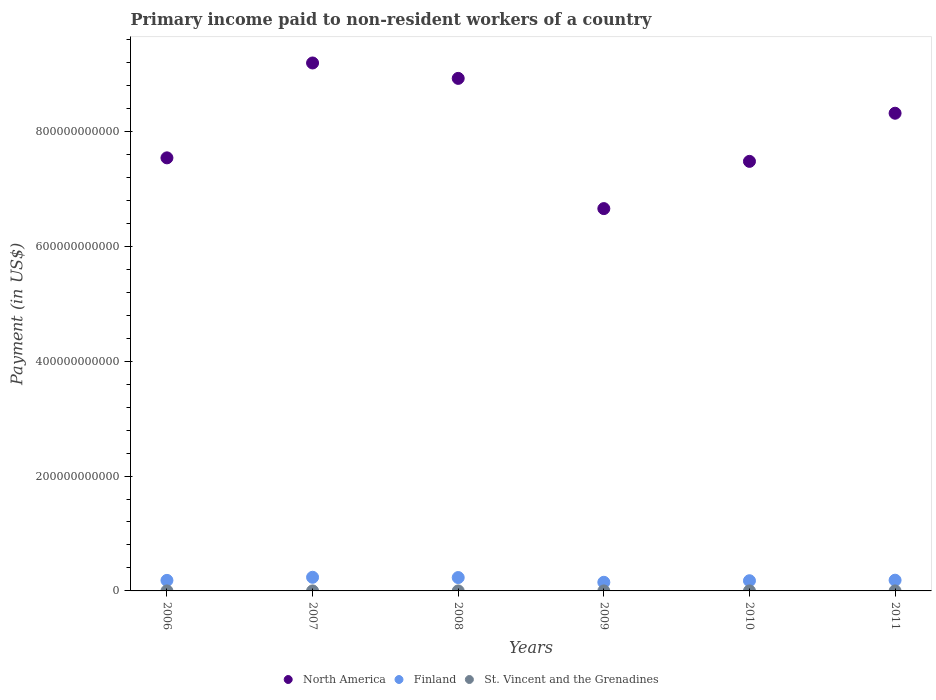How many different coloured dotlines are there?
Provide a succinct answer. 3. Is the number of dotlines equal to the number of legend labels?
Your answer should be compact. Yes. What is the amount paid to workers in Finland in 2009?
Provide a short and direct response. 1.50e+1. Across all years, what is the maximum amount paid to workers in North America?
Offer a terse response. 9.19e+11. Across all years, what is the minimum amount paid to workers in St. Vincent and the Grenadines?
Give a very brief answer. 9.53e+06. In which year was the amount paid to workers in North America maximum?
Keep it short and to the point. 2007. What is the total amount paid to workers in St. Vincent and the Grenadines in the graph?
Offer a very short reply. 7.30e+07. What is the difference between the amount paid to workers in North America in 2009 and that in 2010?
Ensure brevity in your answer.  -8.22e+1. What is the difference between the amount paid to workers in North America in 2006 and the amount paid to workers in Finland in 2010?
Keep it short and to the point. 7.36e+11. What is the average amount paid to workers in St. Vincent and the Grenadines per year?
Give a very brief answer. 1.22e+07. In the year 2006, what is the difference between the amount paid to workers in Finland and amount paid to workers in North America?
Provide a succinct answer. -7.36e+11. In how many years, is the amount paid to workers in St. Vincent and the Grenadines greater than 800000000000 US$?
Your response must be concise. 0. What is the ratio of the amount paid to workers in St. Vincent and the Grenadines in 2006 to that in 2010?
Provide a succinct answer. 1.07. Is the amount paid to workers in North America in 2006 less than that in 2010?
Provide a short and direct response. No. Is the difference between the amount paid to workers in Finland in 2007 and 2011 greater than the difference between the amount paid to workers in North America in 2007 and 2011?
Ensure brevity in your answer.  No. What is the difference between the highest and the second highest amount paid to workers in St. Vincent and the Grenadines?
Provide a short and direct response. 8.47e+04. What is the difference between the highest and the lowest amount paid to workers in Finland?
Provide a short and direct response. 8.73e+09. In how many years, is the amount paid to workers in North America greater than the average amount paid to workers in North America taken over all years?
Make the answer very short. 3. Is the sum of the amount paid to workers in Finland in 2006 and 2007 greater than the maximum amount paid to workers in St. Vincent and the Grenadines across all years?
Your answer should be compact. Yes. Does the amount paid to workers in St. Vincent and the Grenadines monotonically increase over the years?
Your answer should be compact. No. Is the amount paid to workers in St. Vincent and the Grenadines strictly greater than the amount paid to workers in Finland over the years?
Your response must be concise. No. How many dotlines are there?
Give a very brief answer. 3. How many years are there in the graph?
Offer a terse response. 6. What is the difference between two consecutive major ticks on the Y-axis?
Make the answer very short. 2.00e+11. Where does the legend appear in the graph?
Make the answer very short. Bottom center. How are the legend labels stacked?
Keep it short and to the point. Horizontal. What is the title of the graph?
Provide a short and direct response. Primary income paid to non-resident workers of a country. What is the label or title of the Y-axis?
Offer a terse response. Payment (in US$). What is the Payment (in US$) of North America in 2006?
Your response must be concise. 7.54e+11. What is the Payment (in US$) of Finland in 2006?
Your answer should be compact. 1.83e+1. What is the Payment (in US$) in St. Vincent and the Grenadines in 2006?
Your answer should be very brief. 1.36e+07. What is the Payment (in US$) of North America in 2007?
Your answer should be very brief. 9.19e+11. What is the Payment (in US$) of Finland in 2007?
Provide a short and direct response. 2.38e+1. What is the Payment (in US$) of St. Vincent and the Grenadines in 2007?
Your answer should be very brief. 1.34e+07. What is the Payment (in US$) of North America in 2008?
Provide a succinct answer. 8.92e+11. What is the Payment (in US$) in Finland in 2008?
Offer a terse response. 2.33e+1. What is the Payment (in US$) in St. Vincent and the Grenadines in 2008?
Keep it short and to the point. 1.01e+07. What is the Payment (in US$) of North America in 2009?
Your answer should be compact. 6.66e+11. What is the Payment (in US$) in Finland in 2009?
Your answer should be compact. 1.50e+1. What is the Payment (in US$) in St. Vincent and the Grenadines in 2009?
Offer a very short reply. 1.37e+07. What is the Payment (in US$) of North America in 2010?
Ensure brevity in your answer.  7.48e+11. What is the Payment (in US$) of Finland in 2010?
Make the answer very short. 1.77e+1. What is the Payment (in US$) of St. Vincent and the Grenadines in 2010?
Your answer should be compact. 1.27e+07. What is the Payment (in US$) in North America in 2011?
Give a very brief answer. 8.32e+11. What is the Payment (in US$) of Finland in 2011?
Ensure brevity in your answer.  1.87e+1. What is the Payment (in US$) in St. Vincent and the Grenadines in 2011?
Keep it short and to the point. 9.53e+06. Across all years, what is the maximum Payment (in US$) of North America?
Give a very brief answer. 9.19e+11. Across all years, what is the maximum Payment (in US$) in Finland?
Offer a very short reply. 2.38e+1. Across all years, what is the maximum Payment (in US$) in St. Vincent and the Grenadines?
Your answer should be compact. 1.37e+07. Across all years, what is the minimum Payment (in US$) in North America?
Provide a succinct answer. 6.66e+11. Across all years, what is the minimum Payment (in US$) in Finland?
Provide a short and direct response. 1.50e+1. Across all years, what is the minimum Payment (in US$) of St. Vincent and the Grenadines?
Make the answer very short. 9.53e+06. What is the total Payment (in US$) in North America in the graph?
Give a very brief answer. 4.81e+12. What is the total Payment (in US$) in Finland in the graph?
Provide a succinct answer. 1.17e+11. What is the total Payment (in US$) in St. Vincent and the Grenadines in the graph?
Offer a very short reply. 7.30e+07. What is the difference between the Payment (in US$) of North America in 2006 and that in 2007?
Provide a succinct answer. -1.65e+11. What is the difference between the Payment (in US$) in Finland in 2006 and that in 2007?
Keep it short and to the point. -5.40e+09. What is the difference between the Payment (in US$) in St. Vincent and the Grenadines in 2006 and that in 2007?
Your response must be concise. 1.92e+05. What is the difference between the Payment (in US$) of North America in 2006 and that in 2008?
Your answer should be compact. -1.38e+11. What is the difference between the Payment (in US$) of Finland in 2006 and that in 2008?
Make the answer very short. -4.91e+09. What is the difference between the Payment (in US$) in St. Vincent and the Grenadines in 2006 and that in 2008?
Your answer should be very brief. 3.48e+06. What is the difference between the Payment (in US$) of North America in 2006 and that in 2009?
Ensure brevity in your answer.  8.84e+1. What is the difference between the Payment (in US$) of Finland in 2006 and that in 2009?
Make the answer very short. 3.33e+09. What is the difference between the Payment (in US$) of St. Vincent and the Grenadines in 2006 and that in 2009?
Provide a short and direct response. -8.47e+04. What is the difference between the Payment (in US$) in North America in 2006 and that in 2010?
Provide a succinct answer. 6.12e+09. What is the difference between the Payment (in US$) in Finland in 2006 and that in 2010?
Keep it short and to the point. 6.00e+08. What is the difference between the Payment (in US$) in St. Vincent and the Grenadines in 2006 and that in 2010?
Make the answer very short. 9.29e+05. What is the difference between the Payment (in US$) of North America in 2006 and that in 2011?
Your answer should be very brief. -7.77e+1. What is the difference between the Payment (in US$) in Finland in 2006 and that in 2011?
Make the answer very short. -3.24e+08. What is the difference between the Payment (in US$) of St. Vincent and the Grenadines in 2006 and that in 2011?
Your response must be concise. 4.07e+06. What is the difference between the Payment (in US$) of North America in 2007 and that in 2008?
Give a very brief answer. 2.68e+1. What is the difference between the Payment (in US$) of Finland in 2007 and that in 2008?
Your answer should be very brief. 4.90e+08. What is the difference between the Payment (in US$) of St. Vincent and the Grenadines in 2007 and that in 2008?
Your response must be concise. 3.29e+06. What is the difference between the Payment (in US$) of North America in 2007 and that in 2009?
Ensure brevity in your answer.  2.54e+11. What is the difference between the Payment (in US$) in Finland in 2007 and that in 2009?
Your answer should be compact. 8.73e+09. What is the difference between the Payment (in US$) in St. Vincent and the Grenadines in 2007 and that in 2009?
Your answer should be very brief. -2.77e+05. What is the difference between the Payment (in US$) in North America in 2007 and that in 2010?
Offer a terse response. 1.71e+11. What is the difference between the Payment (in US$) in Finland in 2007 and that in 2010?
Your response must be concise. 6.00e+09. What is the difference between the Payment (in US$) in St. Vincent and the Grenadines in 2007 and that in 2010?
Provide a succinct answer. 7.36e+05. What is the difference between the Payment (in US$) in North America in 2007 and that in 2011?
Your answer should be very brief. 8.75e+1. What is the difference between the Payment (in US$) in Finland in 2007 and that in 2011?
Keep it short and to the point. 5.08e+09. What is the difference between the Payment (in US$) of St. Vincent and the Grenadines in 2007 and that in 2011?
Your answer should be very brief. 3.88e+06. What is the difference between the Payment (in US$) in North America in 2008 and that in 2009?
Make the answer very short. 2.27e+11. What is the difference between the Payment (in US$) in Finland in 2008 and that in 2009?
Keep it short and to the point. 8.24e+09. What is the difference between the Payment (in US$) of St. Vincent and the Grenadines in 2008 and that in 2009?
Give a very brief answer. -3.57e+06. What is the difference between the Payment (in US$) in North America in 2008 and that in 2010?
Make the answer very short. 1.44e+11. What is the difference between the Payment (in US$) of Finland in 2008 and that in 2010?
Make the answer very short. 5.51e+09. What is the difference between the Payment (in US$) of St. Vincent and the Grenadines in 2008 and that in 2010?
Your answer should be very brief. -2.55e+06. What is the difference between the Payment (in US$) of North America in 2008 and that in 2011?
Your answer should be very brief. 6.07e+1. What is the difference between the Payment (in US$) in Finland in 2008 and that in 2011?
Ensure brevity in your answer.  4.59e+09. What is the difference between the Payment (in US$) in St. Vincent and the Grenadines in 2008 and that in 2011?
Provide a short and direct response. 5.87e+05. What is the difference between the Payment (in US$) of North America in 2009 and that in 2010?
Offer a very short reply. -8.22e+1. What is the difference between the Payment (in US$) of Finland in 2009 and that in 2010?
Offer a terse response. -2.73e+09. What is the difference between the Payment (in US$) of St. Vincent and the Grenadines in 2009 and that in 2010?
Your response must be concise. 1.01e+06. What is the difference between the Payment (in US$) of North America in 2009 and that in 2011?
Your answer should be very brief. -1.66e+11. What is the difference between the Payment (in US$) in Finland in 2009 and that in 2011?
Your response must be concise. -3.65e+09. What is the difference between the Payment (in US$) in St. Vincent and the Grenadines in 2009 and that in 2011?
Keep it short and to the point. 4.16e+06. What is the difference between the Payment (in US$) in North America in 2010 and that in 2011?
Keep it short and to the point. -8.38e+1. What is the difference between the Payment (in US$) of Finland in 2010 and that in 2011?
Ensure brevity in your answer.  -9.24e+08. What is the difference between the Payment (in US$) in St. Vincent and the Grenadines in 2010 and that in 2011?
Keep it short and to the point. 3.14e+06. What is the difference between the Payment (in US$) of North America in 2006 and the Payment (in US$) of Finland in 2007?
Provide a short and direct response. 7.30e+11. What is the difference between the Payment (in US$) in North America in 2006 and the Payment (in US$) in St. Vincent and the Grenadines in 2007?
Your response must be concise. 7.54e+11. What is the difference between the Payment (in US$) in Finland in 2006 and the Payment (in US$) in St. Vincent and the Grenadines in 2007?
Provide a short and direct response. 1.83e+1. What is the difference between the Payment (in US$) in North America in 2006 and the Payment (in US$) in Finland in 2008?
Give a very brief answer. 7.31e+11. What is the difference between the Payment (in US$) in North America in 2006 and the Payment (in US$) in St. Vincent and the Grenadines in 2008?
Offer a terse response. 7.54e+11. What is the difference between the Payment (in US$) of Finland in 2006 and the Payment (in US$) of St. Vincent and the Grenadines in 2008?
Your answer should be compact. 1.83e+1. What is the difference between the Payment (in US$) of North America in 2006 and the Payment (in US$) of Finland in 2009?
Your response must be concise. 7.39e+11. What is the difference between the Payment (in US$) in North America in 2006 and the Payment (in US$) in St. Vincent and the Grenadines in 2009?
Provide a succinct answer. 7.54e+11. What is the difference between the Payment (in US$) in Finland in 2006 and the Payment (in US$) in St. Vincent and the Grenadines in 2009?
Provide a short and direct response. 1.83e+1. What is the difference between the Payment (in US$) of North America in 2006 and the Payment (in US$) of Finland in 2010?
Offer a very short reply. 7.36e+11. What is the difference between the Payment (in US$) in North America in 2006 and the Payment (in US$) in St. Vincent and the Grenadines in 2010?
Keep it short and to the point. 7.54e+11. What is the difference between the Payment (in US$) in Finland in 2006 and the Payment (in US$) in St. Vincent and the Grenadines in 2010?
Give a very brief answer. 1.83e+1. What is the difference between the Payment (in US$) in North America in 2006 and the Payment (in US$) in Finland in 2011?
Provide a short and direct response. 7.35e+11. What is the difference between the Payment (in US$) of North America in 2006 and the Payment (in US$) of St. Vincent and the Grenadines in 2011?
Make the answer very short. 7.54e+11. What is the difference between the Payment (in US$) in Finland in 2006 and the Payment (in US$) in St. Vincent and the Grenadines in 2011?
Keep it short and to the point. 1.83e+1. What is the difference between the Payment (in US$) in North America in 2007 and the Payment (in US$) in Finland in 2008?
Make the answer very short. 8.96e+11. What is the difference between the Payment (in US$) of North America in 2007 and the Payment (in US$) of St. Vincent and the Grenadines in 2008?
Your answer should be very brief. 9.19e+11. What is the difference between the Payment (in US$) in Finland in 2007 and the Payment (in US$) in St. Vincent and the Grenadines in 2008?
Make the answer very short. 2.37e+1. What is the difference between the Payment (in US$) in North America in 2007 and the Payment (in US$) in Finland in 2009?
Keep it short and to the point. 9.04e+11. What is the difference between the Payment (in US$) of North America in 2007 and the Payment (in US$) of St. Vincent and the Grenadines in 2009?
Offer a very short reply. 9.19e+11. What is the difference between the Payment (in US$) in Finland in 2007 and the Payment (in US$) in St. Vincent and the Grenadines in 2009?
Make the answer very short. 2.37e+1. What is the difference between the Payment (in US$) of North America in 2007 and the Payment (in US$) of Finland in 2010?
Provide a succinct answer. 9.01e+11. What is the difference between the Payment (in US$) in North America in 2007 and the Payment (in US$) in St. Vincent and the Grenadines in 2010?
Give a very brief answer. 9.19e+11. What is the difference between the Payment (in US$) in Finland in 2007 and the Payment (in US$) in St. Vincent and the Grenadines in 2010?
Give a very brief answer. 2.37e+1. What is the difference between the Payment (in US$) in North America in 2007 and the Payment (in US$) in Finland in 2011?
Provide a short and direct response. 9.00e+11. What is the difference between the Payment (in US$) in North America in 2007 and the Payment (in US$) in St. Vincent and the Grenadines in 2011?
Make the answer very short. 9.19e+11. What is the difference between the Payment (in US$) of Finland in 2007 and the Payment (in US$) of St. Vincent and the Grenadines in 2011?
Make the answer very short. 2.37e+1. What is the difference between the Payment (in US$) of North America in 2008 and the Payment (in US$) of Finland in 2009?
Provide a succinct answer. 8.77e+11. What is the difference between the Payment (in US$) in North America in 2008 and the Payment (in US$) in St. Vincent and the Grenadines in 2009?
Make the answer very short. 8.92e+11. What is the difference between the Payment (in US$) of Finland in 2008 and the Payment (in US$) of St. Vincent and the Grenadines in 2009?
Ensure brevity in your answer.  2.32e+1. What is the difference between the Payment (in US$) of North America in 2008 and the Payment (in US$) of Finland in 2010?
Your response must be concise. 8.74e+11. What is the difference between the Payment (in US$) of North America in 2008 and the Payment (in US$) of St. Vincent and the Grenadines in 2010?
Ensure brevity in your answer.  8.92e+11. What is the difference between the Payment (in US$) of Finland in 2008 and the Payment (in US$) of St. Vincent and the Grenadines in 2010?
Offer a very short reply. 2.32e+1. What is the difference between the Payment (in US$) of North America in 2008 and the Payment (in US$) of Finland in 2011?
Make the answer very short. 8.74e+11. What is the difference between the Payment (in US$) in North America in 2008 and the Payment (in US$) in St. Vincent and the Grenadines in 2011?
Provide a succinct answer. 8.92e+11. What is the difference between the Payment (in US$) of Finland in 2008 and the Payment (in US$) of St. Vincent and the Grenadines in 2011?
Offer a terse response. 2.33e+1. What is the difference between the Payment (in US$) of North America in 2009 and the Payment (in US$) of Finland in 2010?
Make the answer very short. 6.48e+11. What is the difference between the Payment (in US$) of North America in 2009 and the Payment (in US$) of St. Vincent and the Grenadines in 2010?
Ensure brevity in your answer.  6.65e+11. What is the difference between the Payment (in US$) in Finland in 2009 and the Payment (in US$) in St. Vincent and the Grenadines in 2010?
Offer a very short reply. 1.50e+1. What is the difference between the Payment (in US$) in North America in 2009 and the Payment (in US$) in Finland in 2011?
Provide a short and direct response. 6.47e+11. What is the difference between the Payment (in US$) of North America in 2009 and the Payment (in US$) of St. Vincent and the Grenadines in 2011?
Your answer should be compact. 6.66e+11. What is the difference between the Payment (in US$) of Finland in 2009 and the Payment (in US$) of St. Vincent and the Grenadines in 2011?
Your answer should be compact. 1.50e+1. What is the difference between the Payment (in US$) of North America in 2010 and the Payment (in US$) of Finland in 2011?
Ensure brevity in your answer.  7.29e+11. What is the difference between the Payment (in US$) in North America in 2010 and the Payment (in US$) in St. Vincent and the Grenadines in 2011?
Provide a succinct answer. 7.48e+11. What is the difference between the Payment (in US$) of Finland in 2010 and the Payment (in US$) of St. Vincent and the Grenadines in 2011?
Your answer should be very brief. 1.77e+1. What is the average Payment (in US$) of North America per year?
Your response must be concise. 8.02e+11. What is the average Payment (in US$) in Finland per year?
Give a very brief answer. 1.95e+1. What is the average Payment (in US$) in St. Vincent and the Grenadines per year?
Keep it short and to the point. 1.22e+07. In the year 2006, what is the difference between the Payment (in US$) in North America and Payment (in US$) in Finland?
Ensure brevity in your answer.  7.36e+11. In the year 2006, what is the difference between the Payment (in US$) of North America and Payment (in US$) of St. Vincent and the Grenadines?
Offer a very short reply. 7.54e+11. In the year 2006, what is the difference between the Payment (in US$) in Finland and Payment (in US$) in St. Vincent and the Grenadines?
Your answer should be very brief. 1.83e+1. In the year 2007, what is the difference between the Payment (in US$) in North America and Payment (in US$) in Finland?
Make the answer very short. 8.95e+11. In the year 2007, what is the difference between the Payment (in US$) of North America and Payment (in US$) of St. Vincent and the Grenadines?
Make the answer very short. 9.19e+11. In the year 2007, what is the difference between the Payment (in US$) of Finland and Payment (in US$) of St. Vincent and the Grenadines?
Your answer should be compact. 2.37e+1. In the year 2008, what is the difference between the Payment (in US$) in North America and Payment (in US$) in Finland?
Make the answer very short. 8.69e+11. In the year 2008, what is the difference between the Payment (in US$) of North America and Payment (in US$) of St. Vincent and the Grenadines?
Make the answer very short. 8.92e+11. In the year 2008, what is the difference between the Payment (in US$) in Finland and Payment (in US$) in St. Vincent and the Grenadines?
Ensure brevity in your answer.  2.33e+1. In the year 2009, what is the difference between the Payment (in US$) of North America and Payment (in US$) of Finland?
Your response must be concise. 6.50e+11. In the year 2009, what is the difference between the Payment (in US$) of North America and Payment (in US$) of St. Vincent and the Grenadines?
Provide a succinct answer. 6.65e+11. In the year 2009, what is the difference between the Payment (in US$) of Finland and Payment (in US$) of St. Vincent and the Grenadines?
Your answer should be very brief. 1.50e+1. In the year 2010, what is the difference between the Payment (in US$) in North America and Payment (in US$) in Finland?
Keep it short and to the point. 7.30e+11. In the year 2010, what is the difference between the Payment (in US$) of North America and Payment (in US$) of St. Vincent and the Grenadines?
Provide a succinct answer. 7.48e+11. In the year 2010, what is the difference between the Payment (in US$) in Finland and Payment (in US$) in St. Vincent and the Grenadines?
Your answer should be very brief. 1.77e+1. In the year 2011, what is the difference between the Payment (in US$) in North America and Payment (in US$) in Finland?
Ensure brevity in your answer.  8.13e+11. In the year 2011, what is the difference between the Payment (in US$) in North America and Payment (in US$) in St. Vincent and the Grenadines?
Your answer should be compact. 8.32e+11. In the year 2011, what is the difference between the Payment (in US$) of Finland and Payment (in US$) of St. Vincent and the Grenadines?
Keep it short and to the point. 1.87e+1. What is the ratio of the Payment (in US$) in North America in 2006 to that in 2007?
Give a very brief answer. 0.82. What is the ratio of the Payment (in US$) in Finland in 2006 to that in 2007?
Make the answer very short. 0.77. What is the ratio of the Payment (in US$) in St. Vincent and the Grenadines in 2006 to that in 2007?
Your response must be concise. 1.01. What is the ratio of the Payment (in US$) of North America in 2006 to that in 2008?
Offer a terse response. 0.84. What is the ratio of the Payment (in US$) in Finland in 2006 to that in 2008?
Ensure brevity in your answer.  0.79. What is the ratio of the Payment (in US$) of St. Vincent and the Grenadines in 2006 to that in 2008?
Give a very brief answer. 1.34. What is the ratio of the Payment (in US$) in North America in 2006 to that in 2009?
Keep it short and to the point. 1.13. What is the ratio of the Payment (in US$) in Finland in 2006 to that in 2009?
Make the answer very short. 1.22. What is the ratio of the Payment (in US$) of St. Vincent and the Grenadines in 2006 to that in 2009?
Your response must be concise. 0.99. What is the ratio of the Payment (in US$) in North America in 2006 to that in 2010?
Provide a succinct answer. 1.01. What is the ratio of the Payment (in US$) in Finland in 2006 to that in 2010?
Ensure brevity in your answer.  1.03. What is the ratio of the Payment (in US$) of St. Vincent and the Grenadines in 2006 to that in 2010?
Give a very brief answer. 1.07. What is the ratio of the Payment (in US$) of North America in 2006 to that in 2011?
Provide a short and direct response. 0.91. What is the ratio of the Payment (in US$) of Finland in 2006 to that in 2011?
Make the answer very short. 0.98. What is the ratio of the Payment (in US$) in St. Vincent and the Grenadines in 2006 to that in 2011?
Provide a short and direct response. 1.43. What is the ratio of the Payment (in US$) of North America in 2007 to that in 2008?
Keep it short and to the point. 1.03. What is the ratio of the Payment (in US$) in Finland in 2007 to that in 2008?
Provide a short and direct response. 1.02. What is the ratio of the Payment (in US$) in St. Vincent and the Grenadines in 2007 to that in 2008?
Provide a succinct answer. 1.33. What is the ratio of the Payment (in US$) in North America in 2007 to that in 2009?
Your answer should be very brief. 1.38. What is the ratio of the Payment (in US$) in Finland in 2007 to that in 2009?
Make the answer very short. 1.58. What is the ratio of the Payment (in US$) in St. Vincent and the Grenadines in 2007 to that in 2009?
Your answer should be very brief. 0.98. What is the ratio of the Payment (in US$) in North America in 2007 to that in 2010?
Ensure brevity in your answer.  1.23. What is the ratio of the Payment (in US$) in Finland in 2007 to that in 2010?
Offer a terse response. 1.34. What is the ratio of the Payment (in US$) of St. Vincent and the Grenadines in 2007 to that in 2010?
Provide a short and direct response. 1.06. What is the ratio of the Payment (in US$) in North America in 2007 to that in 2011?
Offer a very short reply. 1.11. What is the ratio of the Payment (in US$) of Finland in 2007 to that in 2011?
Keep it short and to the point. 1.27. What is the ratio of the Payment (in US$) of St. Vincent and the Grenadines in 2007 to that in 2011?
Offer a very short reply. 1.41. What is the ratio of the Payment (in US$) of North America in 2008 to that in 2009?
Make the answer very short. 1.34. What is the ratio of the Payment (in US$) of Finland in 2008 to that in 2009?
Keep it short and to the point. 1.55. What is the ratio of the Payment (in US$) of St. Vincent and the Grenadines in 2008 to that in 2009?
Give a very brief answer. 0.74. What is the ratio of the Payment (in US$) of North America in 2008 to that in 2010?
Your answer should be very brief. 1.19. What is the ratio of the Payment (in US$) in Finland in 2008 to that in 2010?
Provide a short and direct response. 1.31. What is the ratio of the Payment (in US$) of St. Vincent and the Grenadines in 2008 to that in 2010?
Your answer should be very brief. 0.8. What is the ratio of the Payment (in US$) in North America in 2008 to that in 2011?
Ensure brevity in your answer.  1.07. What is the ratio of the Payment (in US$) in Finland in 2008 to that in 2011?
Make the answer very short. 1.25. What is the ratio of the Payment (in US$) in St. Vincent and the Grenadines in 2008 to that in 2011?
Your answer should be compact. 1.06. What is the ratio of the Payment (in US$) in North America in 2009 to that in 2010?
Make the answer very short. 0.89. What is the ratio of the Payment (in US$) in Finland in 2009 to that in 2010?
Provide a succinct answer. 0.85. What is the ratio of the Payment (in US$) in North America in 2009 to that in 2011?
Provide a short and direct response. 0.8. What is the ratio of the Payment (in US$) in Finland in 2009 to that in 2011?
Offer a terse response. 0.8. What is the ratio of the Payment (in US$) of St. Vincent and the Grenadines in 2009 to that in 2011?
Offer a very short reply. 1.44. What is the ratio of the Payment (in US$) in North America in 2010 to that in 2011?
Offer a terse response. 0.9. What is the ratio of the Payment (in US$) of Finland in 2010 to that in 2011?
Make the answer very short. 0.95. What is the ratio of the Payment (in US$) of St. Vincent and the Grenadines in 2010 to that in 2011?
Make the answer very short. 1.33. What is the difference between the highest and the second highest Payment (in US$) in North America?
Provide a short and direct response. 2.68e+1. What is the difference between the highest and the second highest Payment (in US$) in Finland?
Give a very brief answer. 4.90e+08. What is the difference between the highest and the second highest Payment (in US$) in St. Vincent and the Grenadines?
Offer a very short reply. 8.47e+04. What is the difference between the highest and the lowest Payment (in US$) in North America?
Keep it short and to the point. 2.54e+11. What is the difference between the highest and the lowest Payment (in US$) in Finland?
Make the answer very short. 8.73e+09. What is the difference between the highest and the lowest Payment (in US$) of St. Vincent and the Grenadines?
Offer a very short reply. 4.16e+06. 